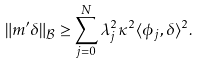Convert formula to latex. <formula><loc_0><loc_0><loc_500><loc_500>\| m ^ { \prime } \delta \| _ { \mathcal { B } } \geq \sum _ { j = 0 } ^ { N } \lambda _ { j } ^ { 2 } \kappa ^ { 2 } \langle \phi _ { j } , \delta \rangle ^ { 2 } .</formula> 